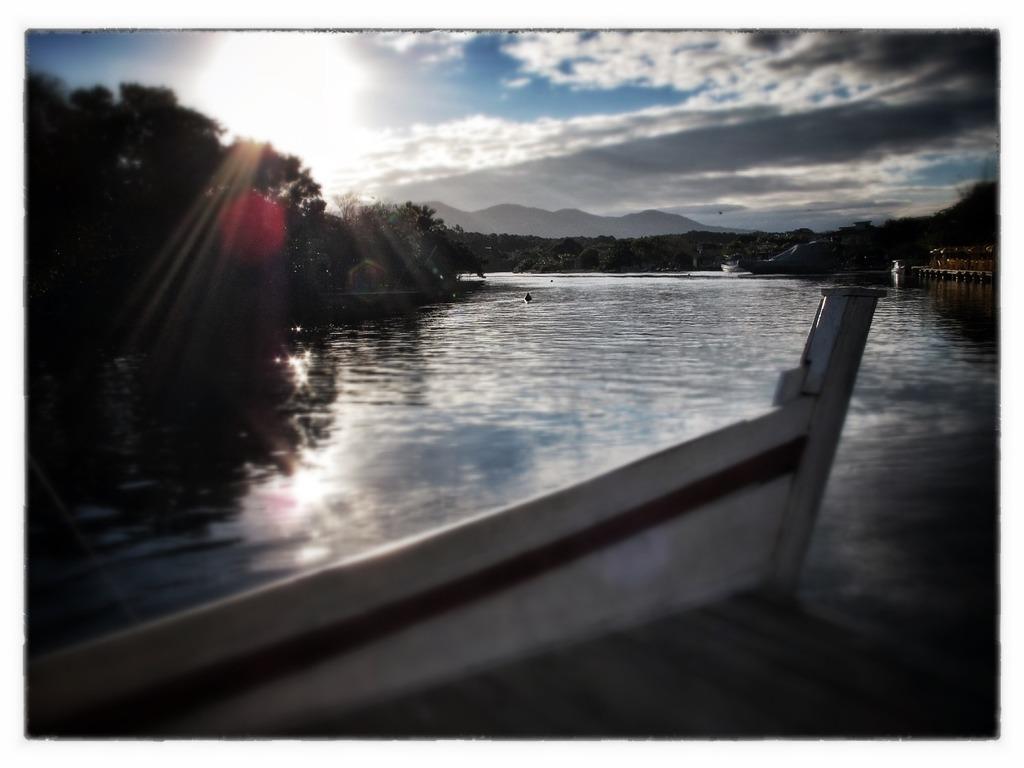Could you give a brief overview of what you see in this image? We can see a dock at the bottom of the image. We can see trees, mountains and lake in the middle of the image. The sky is in blue color with clouds. 